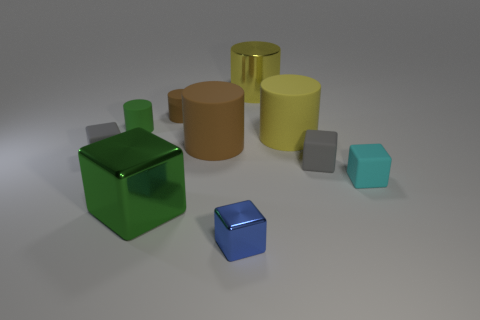There is a small metal block; does it have the same color as the large rubber cylinder that is left of the small metal object?
Ensure brevity in your answer.  No. The large metal object that is in front of the rubber cube that is right of the tiny gray matte block on the right side of the small green matte cylinder is what color?
Give a very brief answer. Green. Are there any other red things that have the same shape as the tiny shiny thing?
Your answer should be compact. No. There is a matte cylinder that is the same size as the yellow matte thing; what color is it?
Offer a very short reply. Brown. What is the gray thing right of the big yellow matte cylinder made of?
Your response must be concise. Rubber. There is a metallic object behind the cyan matte object; is it the same shape as the small gray rubber thing to the left of the big yellow rubber cylinder?
Your response must be concise. No. Are there an equal number of small cyan rubber objects that are behind the large brown cylinder and blue metal cubes?
Offer a very short reply. No. How many large green blocks have the same material as the blue object?
Your response must be concise. 1. What color is the other tiny cylinder that is the same material as the tiny brown cylinder?
Offer a very short reply. Green. Does the green cube have the same size as the gray matte cube that is on the right side of the blue thing?
Offer a terse response. No. 